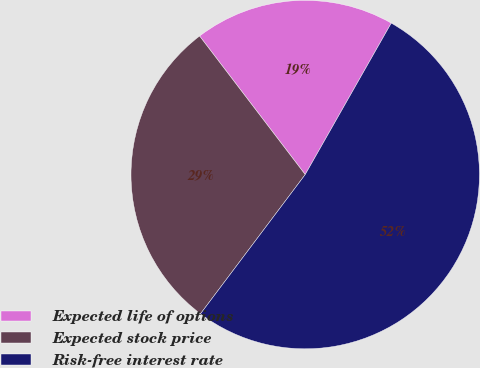Convert chart to OTSL. <chart><loc_0><loc_0><loc_500><loc_500><pie_chart><fcel>Expected life of options<fcel>Expected stock price<fcel>Risk-free interest rate<nl><fcel>18.59%<fcel>29.37%<fcel>52.04%<nl></chart> 